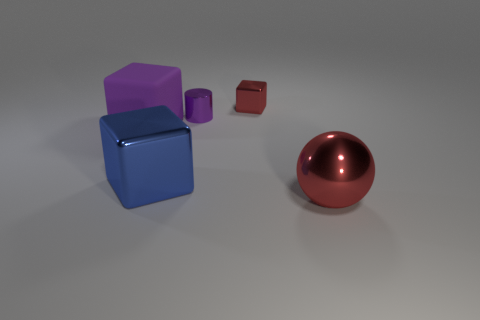The other red object that is the same size as the matte object is what shape?
Make the answer very short. Sphere. Is there a big shiny cube that has the same color as the tiny metal block?
Offer a very short reply. No. Is the shape of the blue thing the same as the large rubber object?
Your response must be concise. Yes. What number of small objects are green rubber spheres or metallic blocks?
Offer a terse response. 1. What color is the big block that is the same material as the tiny cylinder?
Offer a very short reply. Blue. How many other spheres have the same material as the big red ball?
Offer a terse response. 0. There is a red metallic thing behind the small purple shiny cylinder; is it the same size as the purple object that is on the right side of the matte object?
Ensure brevity in your answer.  Yes. What material is the purple object that is on the right side of the purple thing that is on the left side of the tiny purple metallic object?
Provide a succinct answer. Metal. Are there fewer matte blocks on the right side of the large red sphere than metal objects that are in front of the small cylinder?
Give a very brief answer. Yes. What is the material of the object that is the same color as the tiny cube?
Your answer should be very brief. Metal. 